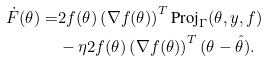<formula> <loc_0><loc_0><loc_500><loc_500>\dot { F } ( \theta ) = & 2 f ( \theta ) \left ( \nabla f ( \theta ) \right ) ^ { T } \text {Proj} _ { \Gamma } ( \theta , y , f ) \\ & - \eta 2 f ( \theta ) \left ( \nabla f ( \theta ) \right ) ^ { T } ( \theta - \hat { \theta } ) .</formula> 